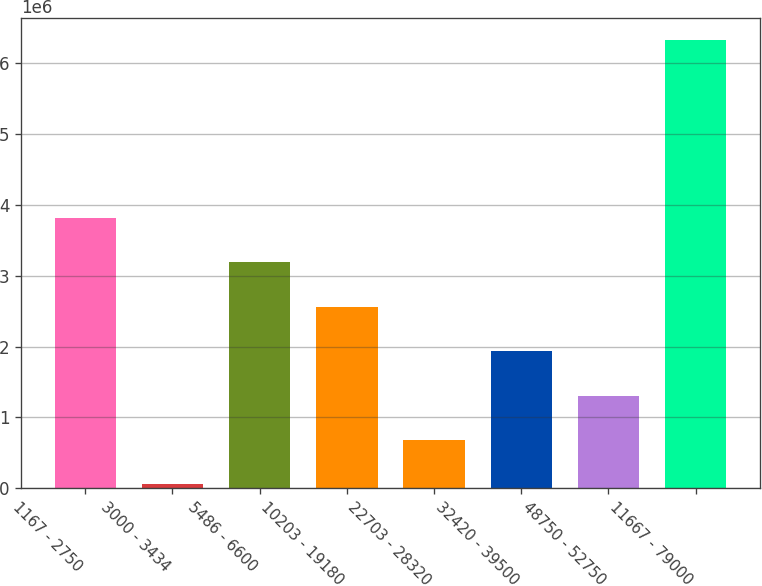<chart> <loc_0><loc_0><loc_500><loc_500><bar_chart><fcel>1167 - 2750<fcel>3000 - 3434<fcel>5486 - 6600<fcel>10203 - 19180<fcel>22703 - 28320<fcel>32420 - 39500<fcel>48750 - 52750<fcel>11667 - 79000<nl><fcel>3.817e+06<fcel>53928<fcel>3.18982e+06<fcel>2.56264e+06<fcel>681106<fcel>1.93546e+06<fcel>1.30828e+06<fcel>6.32571e+06<nl></chart> 